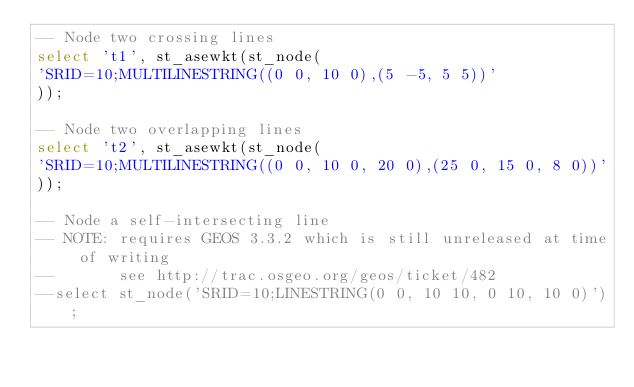<code> <loc_0><loc_0><loc_500><loc_500><_SQL_>-- Node two crossing lines
select 't1', st_asewkt(st_node(
'SRID=10;MULTILINESTRING((0 0, 10 0),(5 -5, 5 5))'
));

-- Node two overlapping lines
select 't2', st_asewkt(st_node(
'SRID=10;MULTILINESTRING((0 0, 10 0, 20 0),(25 0, 15 0, 8 0))'
));

-- Node a self-intersecting line
-- NOTE: requires GEOS 3.3.2 which is still unreleased at time of writing
--       see http://trac.osgeo.org/geos/ticket/482
--select st_node('SRID=10;LINESTRING(0 0, 10 10, 0 10, 10 0)');
</code> 